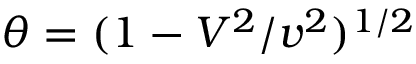Convert formula to latex. <formula><loc_0><loc_0><loc_500><loc_500>\theta = ( 1 - V ^ { 2 } / v ^ { 2 } ) ^ { 1 / 2 }</formula> 